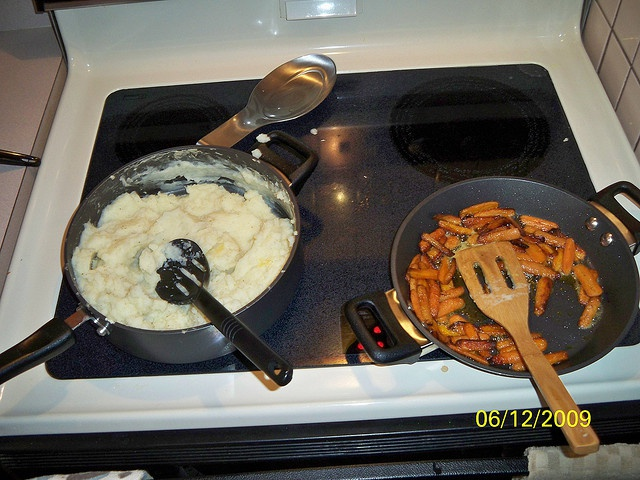Describe the objects in this image and their specific colors. I can see oven in black, darkgray, gray, and beige tones, carrot in black, brown, maroon, and red tones, spoon in black, maroon, gray, and brown tones, spoon in black, darkgray, and gray tones, and carrot in black, red, orange, and maroon tones in this image. 